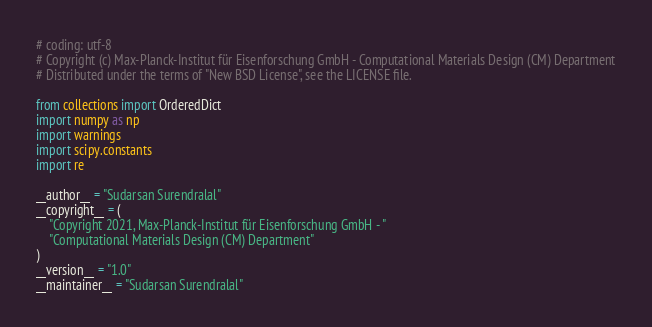Convert code to text. <code><loc_0><loc_0><loc_500><loc_500><_Python_># coding: utf-8
# Copyright (c) Max-Planck-Institut für Eisenforschung GmbH - Computational Materials Design (CM) Department
# Distributed under the terms of "New BSD License", see the LICENSE file.

from collections import OrderedDict
import numpy as np
import warnings
import scipy.constants
import re

__author__ = "Sudarsan Surendralal"
__copyright__ = (
    "Copyright 2021, Max-Planck-Institut für Eisenforschung GmbH - "
    "Computational Materials Design (CM) Department"
)
__version__ = "1.0"
__maintainer__ = "Sudarsan Surendralal"</code> 